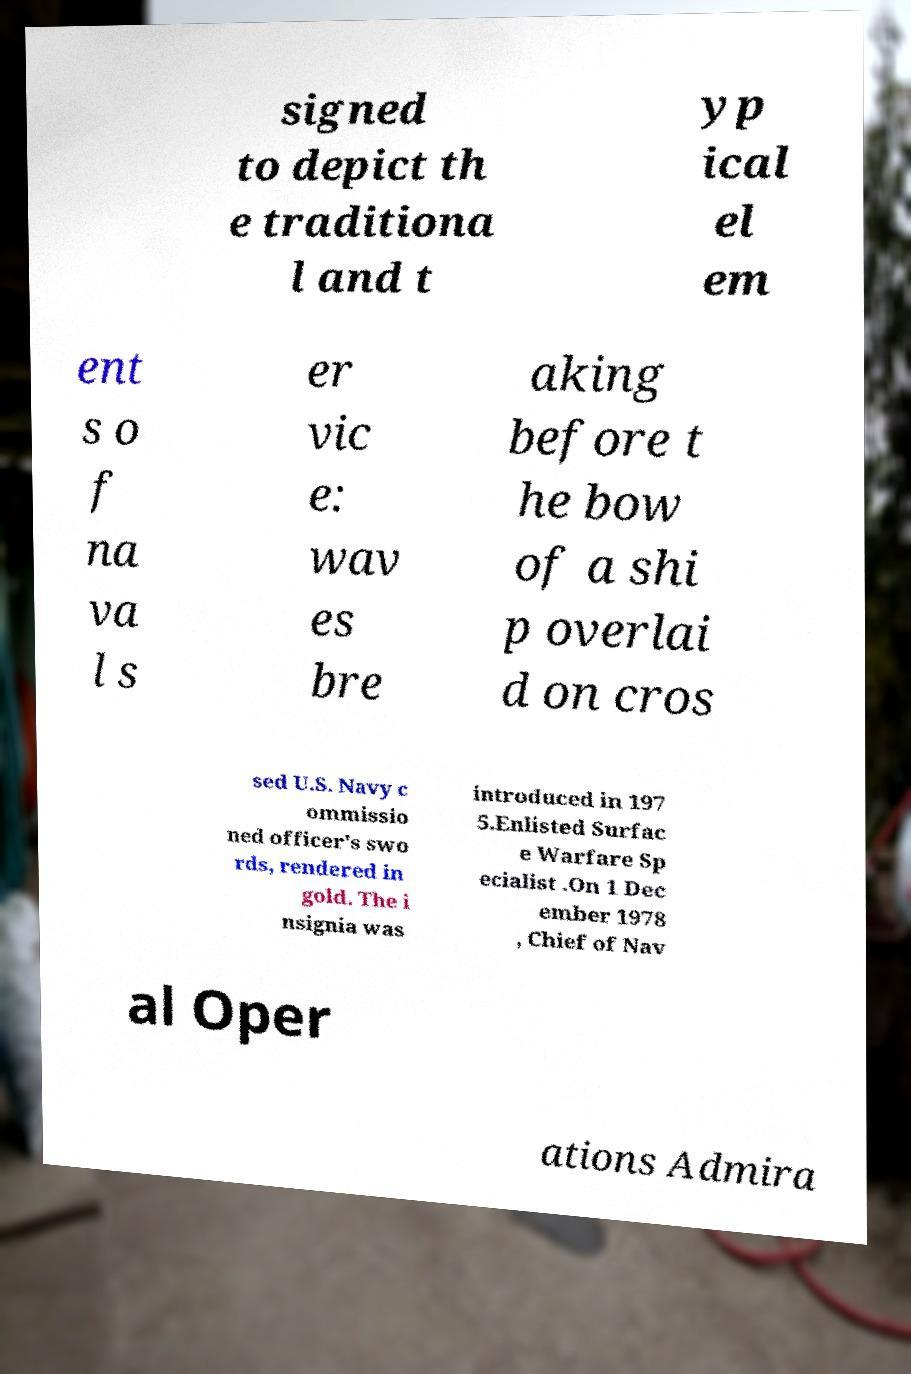I need the written content from this picture converted into text. Can you do that? signed to depict th e traditiona l and t yp ical el em ent s o f na va l s er vic e: wav es bre aking before t he bow of a shi p overlai d on cros sed U.S. Navy c ommissio ned officer's swo rds, rendered in gold. The i nsignia was introduced in 197 5.Enlisted Surfac e Warfare Sp ecialist .On 1 Dec ember 1978 , Chief of Nav al Oper ations Admira 